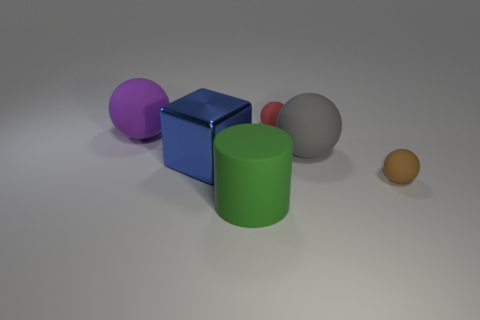Add 1 small gray metal objects. How many objects exist? 7 Subtract all tiny green cylinders. Subtract all brown spheres. How many objects are left? 5 Add 4 large green cylinders. How many large green cylinders are left? 5 Add 3 tiny red things. How many tiny red things exist? 4 Subtract all gray spheres. How many spheres are left? 3 Subtract all big gray matte balls. How many balls are left? 3 Subtract 1 brown spheres. How many objects are left? 5 Subtract all cylinders. How many objects are left? 5 Subtract 2 balls. How many balls are left? 2 Subtract all yellow cylinders. Subtract all brown cubes. How many cylinders are left? 1 